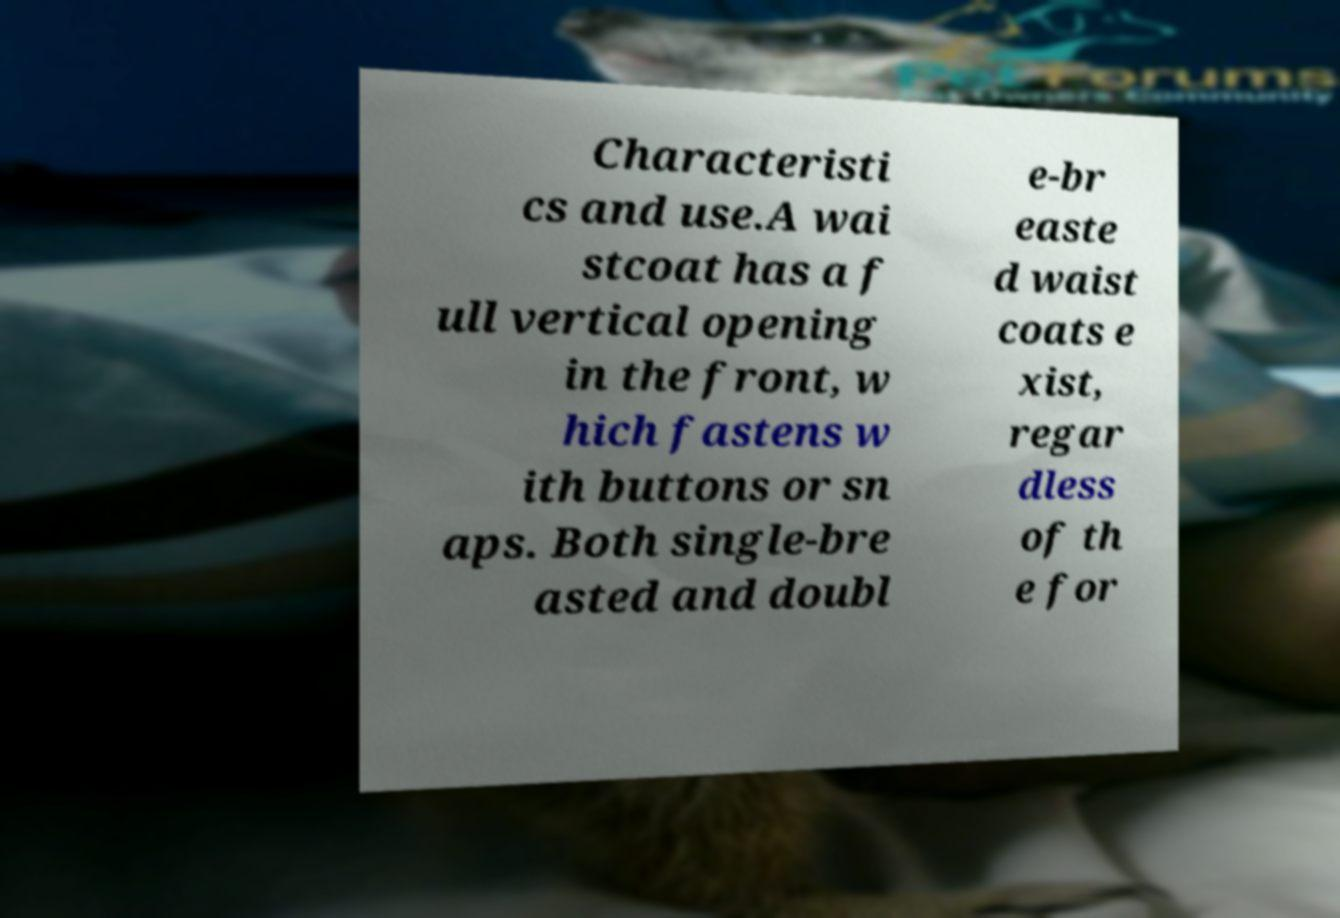For documentation purposes, I need the text within this image transcribed. Could you provide that? Characteristi cs and use.A wai stcoat has a f ull vertical opening in the front, w hich fastens w ith buttons or sn aps. Both single-bre asted and doubl e-br easte d waist coats e xist, regar dless of th e for 